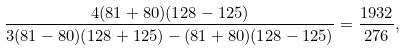Convert formula to latex. <formula><loc_0><loc_0><loc_500><loc_500>\frac { 4 ( 8 1 + 8 0 ) ( 1 2 8 - 1 2 5 ) } { 3 ( 8 1 - 8 0 ) ( 1 2 8 + 1 2 5 ) - ( 8 1 + 8 0 ) ( 1 2 8 - 1 2 5 ) } = \frac { 1 9 3 2 } { 2 7 6 } ,</formula> 